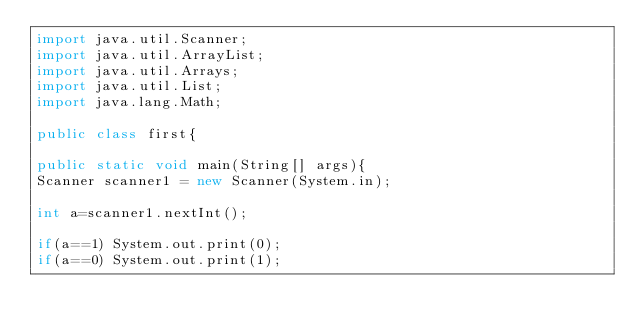<code> <loc_0><loc_0><loc_500><loc_500><_Java_>import java.util.Scanner;
import java.util.ArrayList;
import java.util.Arrays;
import java.util.List;
import java.lang.Math;

public class first{

public static void main(String[] args){
Scanner scanner1 = new Scanner(System.in);

int a=scanner1.nextInt();

if(a==1) System.out.print(0);
if(a==0) System.out.print(1);</code> 